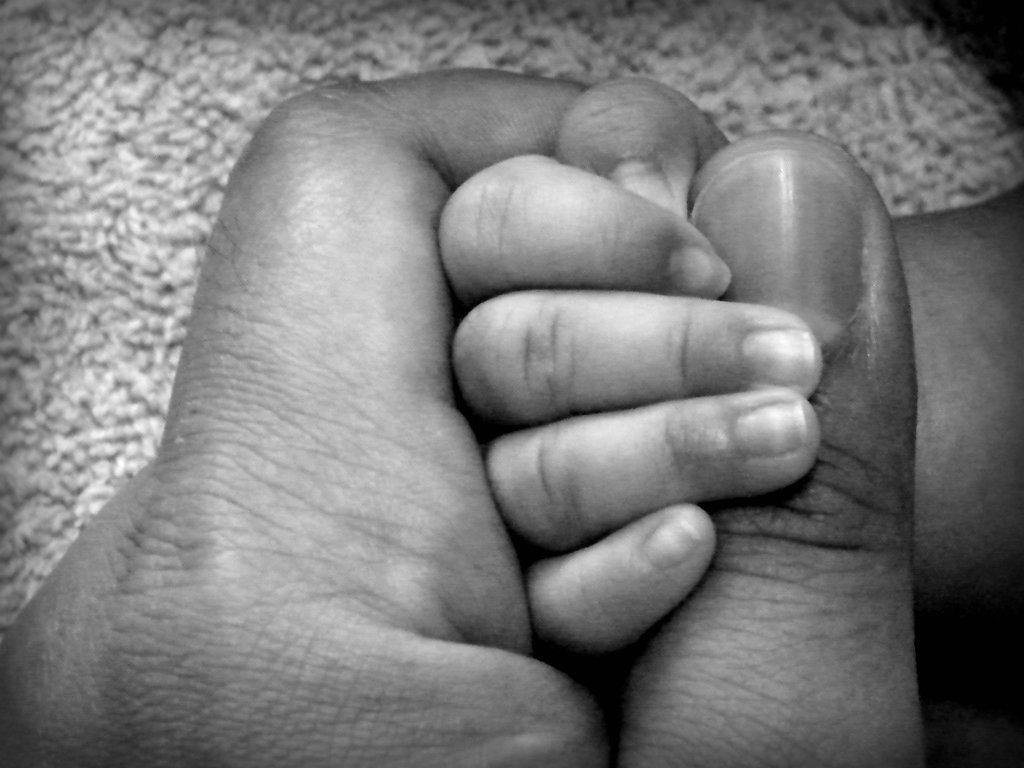What is happening between the person and the infant in the image? The person is holding the infant's hand in the image. What is the color scheme of the image? The image is in black and white. What type of flooring is visible in the background of the image? There is a carpet in the background of the image. How many brothers are present in the image? There is no mention of brothers in the image, as it only shows a person holding an infant's hand. 